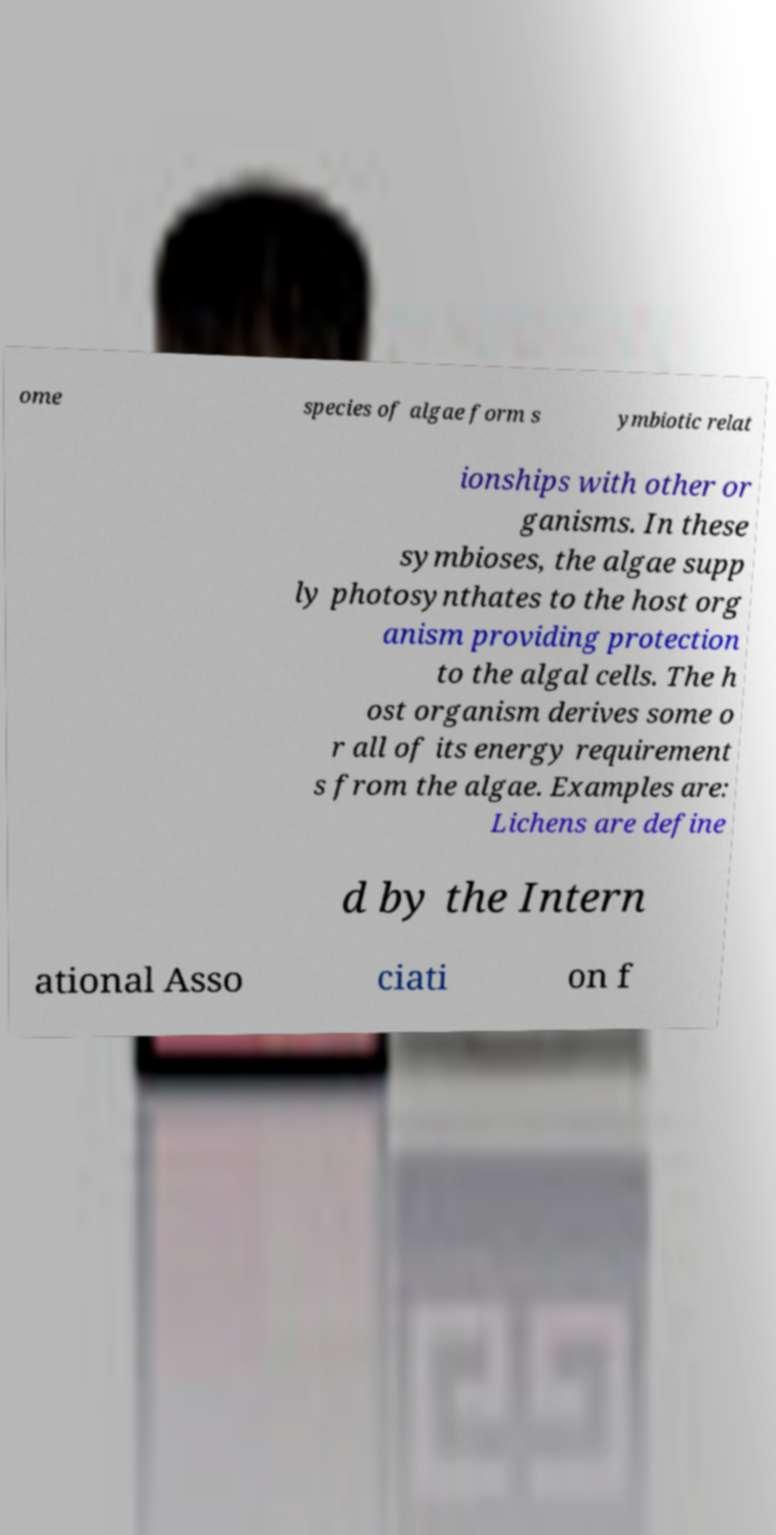Can you accurately transcribe the text from the provided image for me? ome species of algae form s ymbiotic relat ionships with other or ganisms. In these symbioses, the algae supp ly photosynthates to the host org anism providing protection to the algal cells. The h ost organism derives some o r all of its energy requirement s from the algae. Examples are: Lichens are define d by the Intern ational Asso ciati on f 